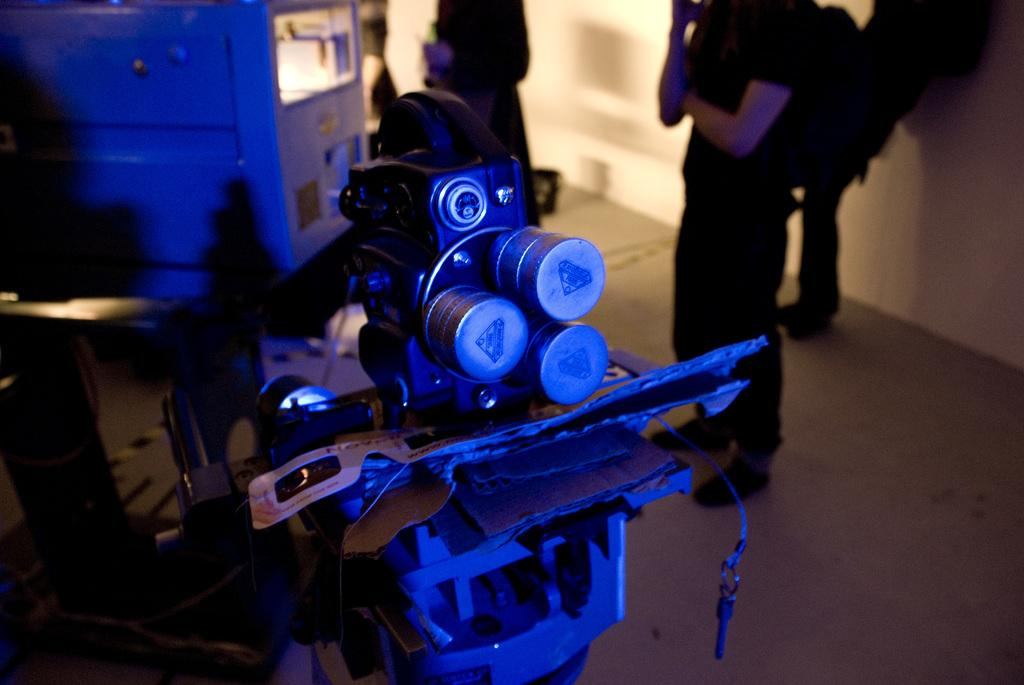What can be seen on the right side of the image? There are persons standing on the right side of the image. Where are the persons standing? The persons are standing on the floor. What is in front of the persons? There are machines in front of the persons. What is visible in the background of the image? There is a wall in the background of the image. What type of tin is being used by the persons in the image? There is no tin present in the image; the persons are standing near machines. 